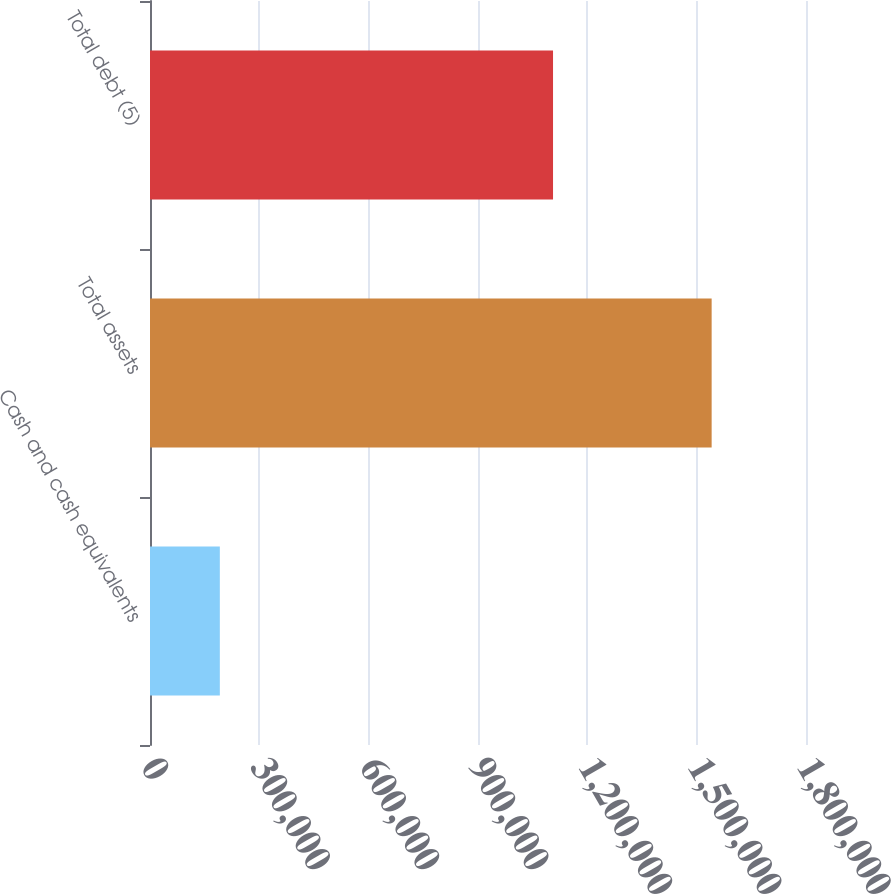Convert chart to OTSL. <chart><loc_0><loc_0><loc_500><loc_500><bar_chart><fcel>Cash and cash equivalents<fcel>Total assets<fcel>Total debt (5)<nl><fcel>191603<fcel>1.54111e+06<fcel>1.10589e+06<nl></chart> 